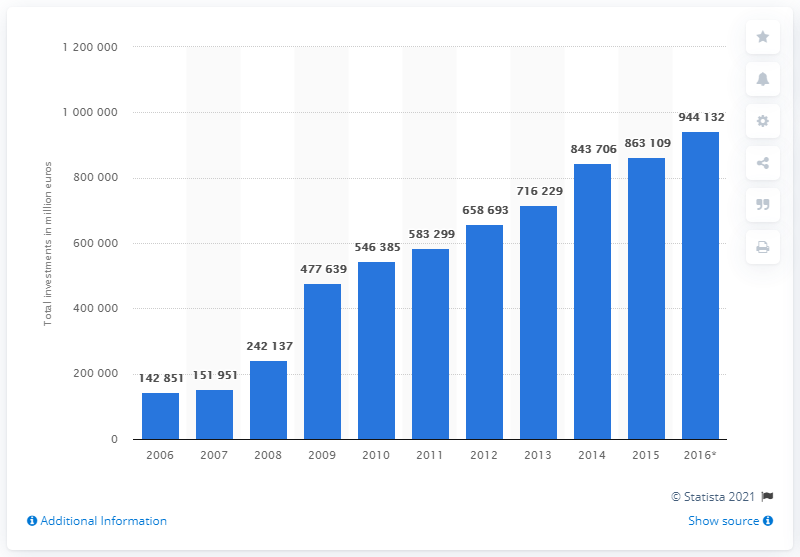Give some essential details in this illustration. In 2016, the total value of investments in investment fund shares or units in the Netherlands was 944,132.. In 2015, the total value of investments in investment fund shares or units was 863,109 and so on. 